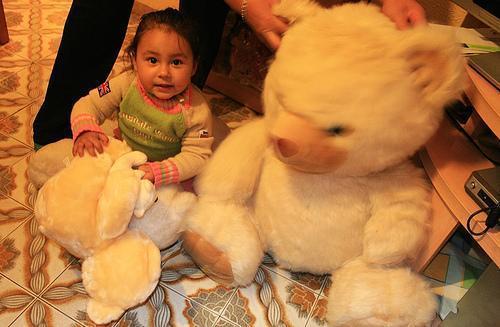How many people on the floor?
Give a very brief answer. 1. 